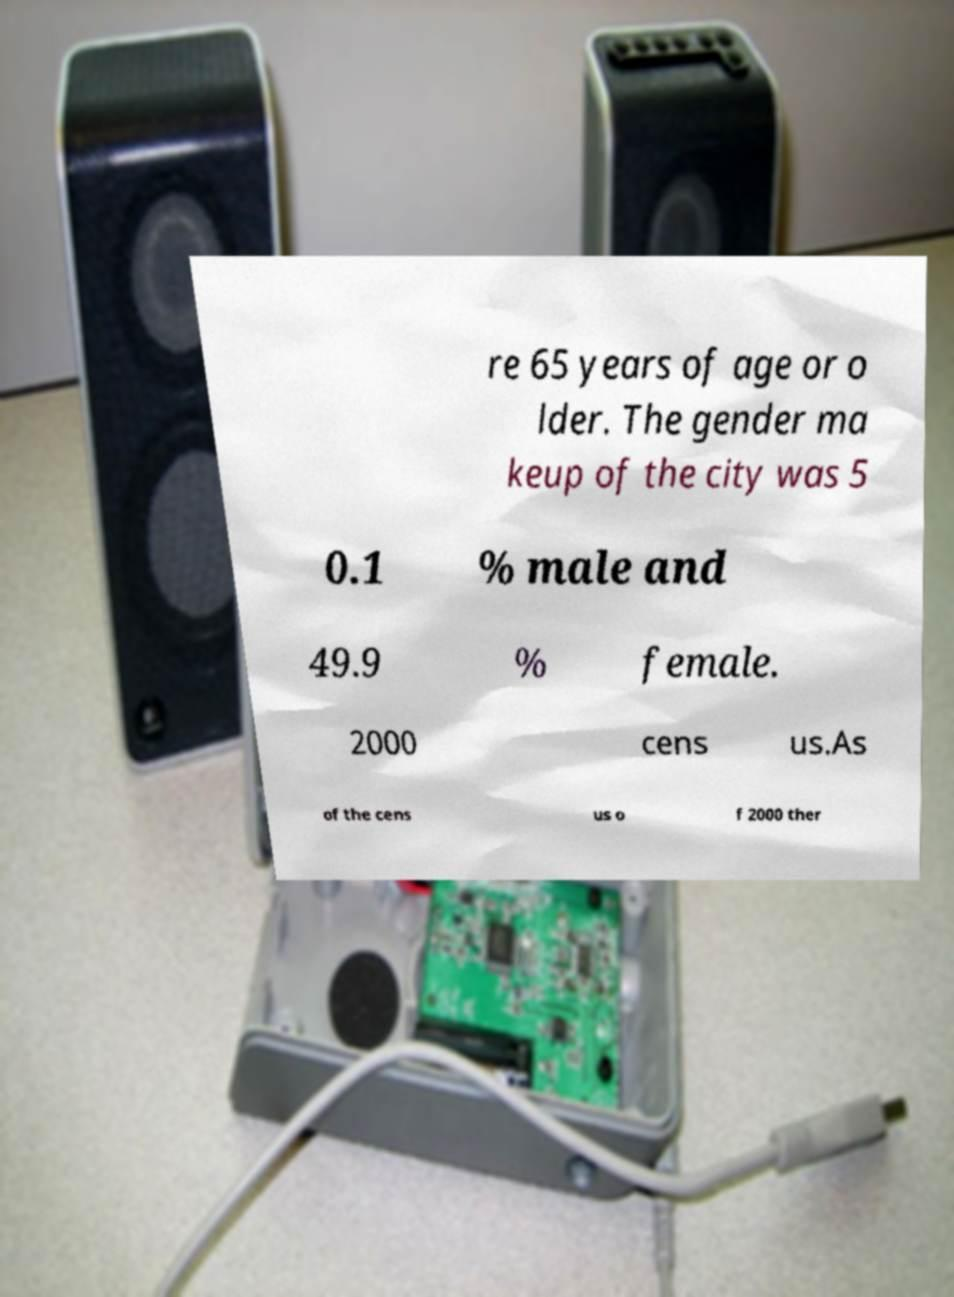Could you extract and type out the text from this image? re 65 years of age or o lder. The gender ma keup of the city was 5 0.1 % male and 49.9 % female. 2000 cens us.As of the cens us o f 2000 ther 